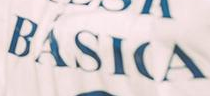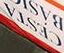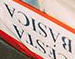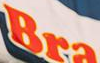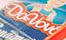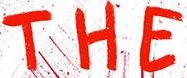Transcribe the words shown in these images in order, separated by a semicolon. BÁSICA; CESTA; BÁSICA; Bra; Davbv; THE 